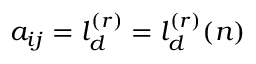<formula> <loc_0><loc_0><loc_500><loc_500>a _ { i j } = l _ { d } ^ { ( r ) } = l _ { d } ^ { ( r ) } ( n )</formula> 